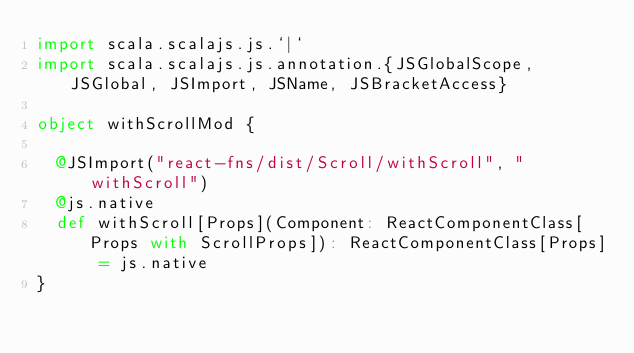Convert code to text. <code><loc_0><loc_0><loc_500><loc_500><_Scala_>import scala.scalajs.js.`|`
import scala.scalajs.js.annotation.{JSGlobalScope, JSGlobal, JSImport, JSName, JSBracketAccess}

object withScrollMod {
  
  @JSImport("react-fns/dist/Scroll/withScroll", "withScroll")
  @js.native
  def withScroll[Props](Component: ReactComponentClass[Props with ScrollProps]): ReactComponentClass[Props] = js.native
}
</code> 